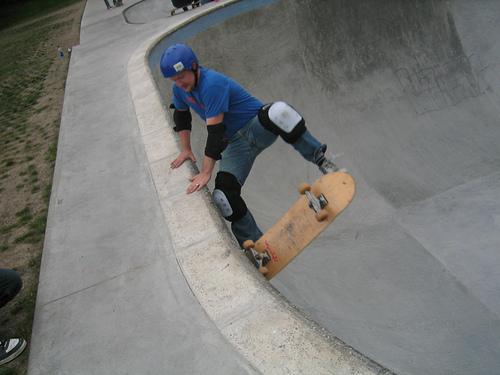What type of lens was this photo taken with?
Concise answer only. Wide. Is he standing on the skateboard?
Concise answer only. No. Are there stickers on the bottom of this board?
Be succinct. No. Does the skater seem balanced?
Short answer required. No. What color is the skateboarders hat?
Keep it brief. Blue. Will they fill this pool with water after he has finished skateboarding in it?
Quick response, please. No. What is on the side of the bowl?
Give a very brief answer. Skateboarder. What color is the man's board?
Be succinct. Tan. Is there a shadow?
Quick response, please. No. Does the skate park look like an empty swimming pool?
Keep it brief. Yes. What color is this person's helmet?
Keep it brief. Blue. What is the color of his helmet?
Give a very brief answer. Blue. 